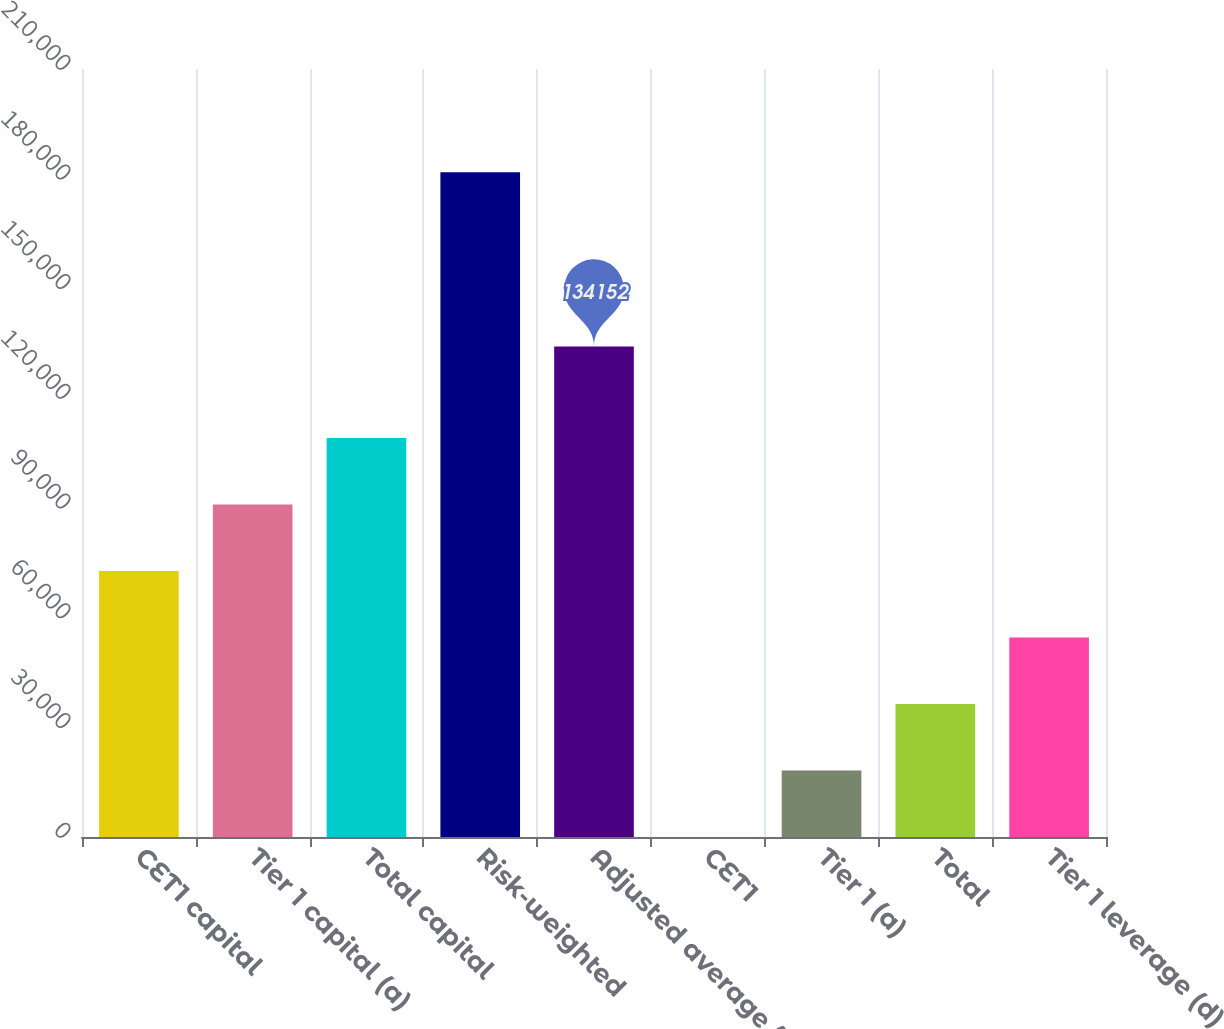Convert chart to OTSL. <chart><loc_0><loc_0><loc_500><loc_500><bar_chart><fcel>CET1 capital<fcel>Tier 1 capital (a)<fcel>Total capital<fcel>Risk-weighted<fcel>Adjusted average (b)<fcel>CET1<fcel>Tier 1 (a)<fcel>Total<fcel>Tier 1 leverage (d)<nl><fcel>72715.1<fcel>90891.8<fcel>109068<fcel>181775<fcel>134152<fcel>8.5<fcel>18185.2<fcel>36361.8<fcel>54538.4<nl></chart> 